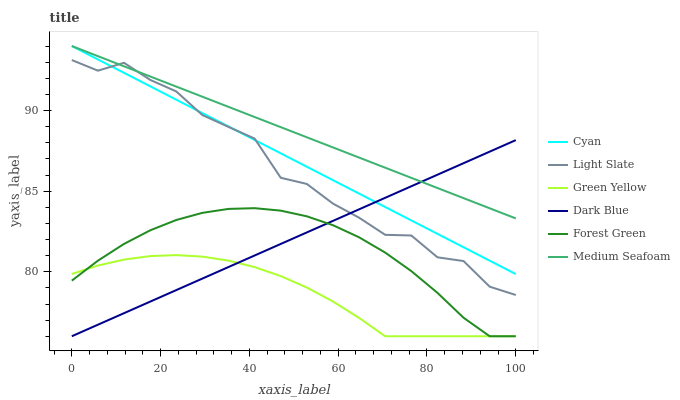Does Green Yellow have the minimum area under the curve?
Answer yes or no. Yes. Does Medium Seafoam have the maximum area under the curve?
Answer yes or no. Yes. Does Dark Blue have the minimum area under the curve?
Answer yes or no. No. Does Dark Blue have the maximum area under the curve?
Answer yes or no. No. Is Medium Seafoam the smoothest?
Answer yes or no. Yes. Is Light Slate the roughest?
Answer yes or no. Yes. Is Dark Blue the smoothest?
Answer yes or no. No. Is Dark Blue the roughest?
Answer yes or no. No. Does Dark Blue have the lowest value?
Answer yes or no. Yes. Does Cyan have the lowest value?
Answer yes or no. No. Does Medium Seafoam have the highest value?
Answer yes or no. Yes. Does Dark Blue have the highest value?
Answer yes or no. No. Is Green Yellow less than Light Slate?
Answer yes or no. Yes. Is Medium Seafoam greater than Forest Green?
Answer yes or no. Yes. Does Green Yellow intersect Forest Green?
Answer yes or no. Yes. Is Green Yellow less than Forest Green?
Answer yes or no. No. Is Green Yellow greater than Forest Green?
Answer yes or no. No. Does Green Yellow intersect Light Slate?
Answer yes or no. No. 